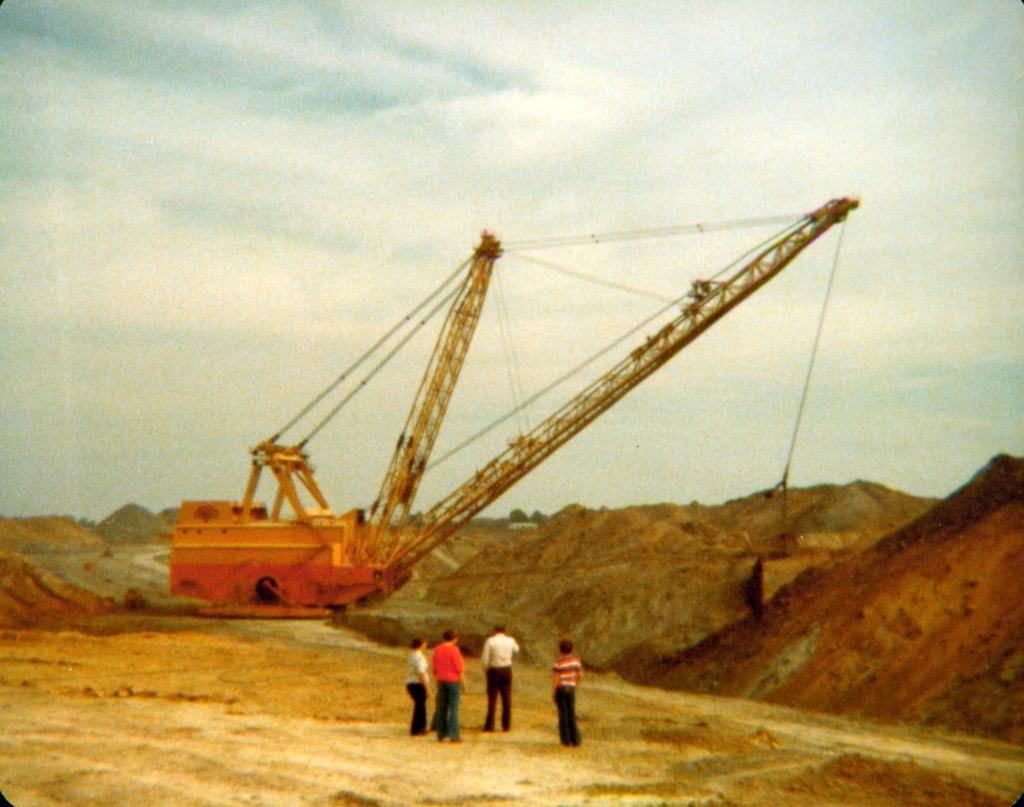How many people are in the image? There is a group of people in the image, but the exact number is not specified. What are the people standing in front of? The people are standing in front of a crane. What type of wind can be seen blowing in the image? There is no wind visible in the image. How many trucks are parked near the crane in the image? The provided facts do not mention any trucks in the image. 